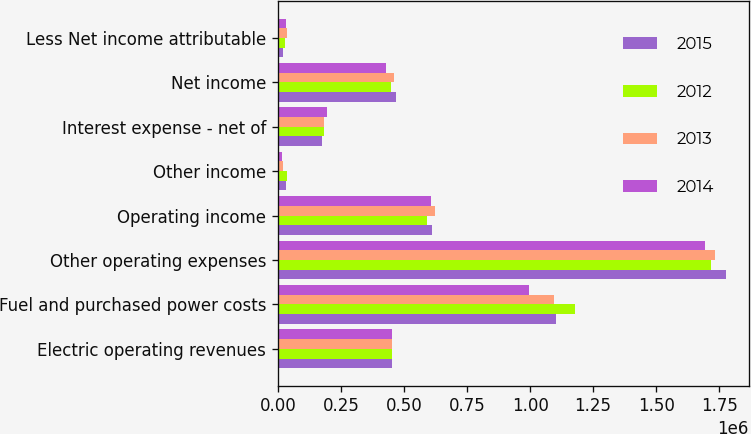Convert chart. <chart><loc_0><loc_0><loc_500><loc_500><stacked_bar_chart><ecel><fcel>Electric operating revenues<fcel>Fuel and purchased power costs<fcel>Other operating expenses<fcel>Operating income<fcel>Other income<fcel>Interest expense - net of<fcel>Net income<fcel>Less Net income attributable<nl><fcel>2015<fcel>453090<fcel>1.1013e+06<fcel>1.77908e+06<fcel>611984<fcel>33332<fcel>176109<fcel>469207<fcel>18933<nl><fcel>2012<fcel>453090<fcel>1.17983e+06<fcel>1.71632e+06<fcel>592792<fcel>36358<fcel>181830<fcel>447320<fcel>26101<nl><fcel>2013<fcel>453090<fcel>1.09571e+06<fcel>1.73368e+06<fcel>621865<fcel>20797<fcel>183801<fcel>458861<fcel>33892<nl><fcel>2014<fcel>453090<fcel>994790<fcel>1.69317e+06<fcel>605529<fcel>16358<fcel>194777<fcel>427110<fcel>31613<nl></chart> 